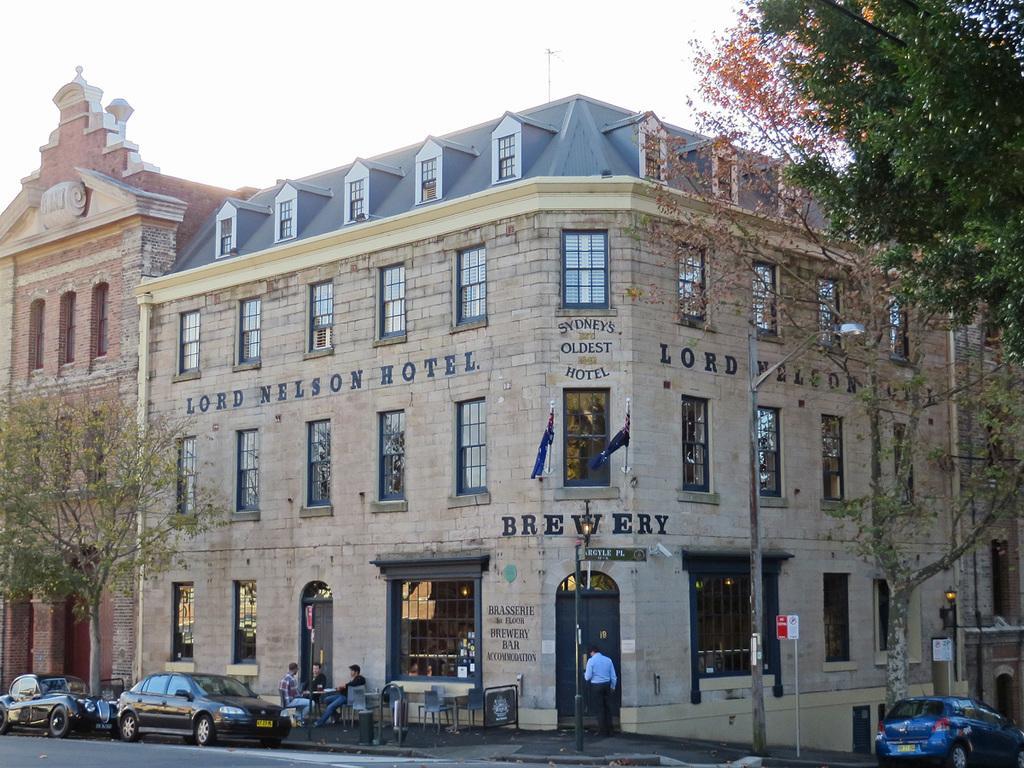In one or two sentences, can you explain what this image depicts? In this image, we can see buildings, trees, poles, boards, vehicles on the road and we can see people and some are sitting on the chairs and there are tables, flags and lights. At the top, there is sky. 